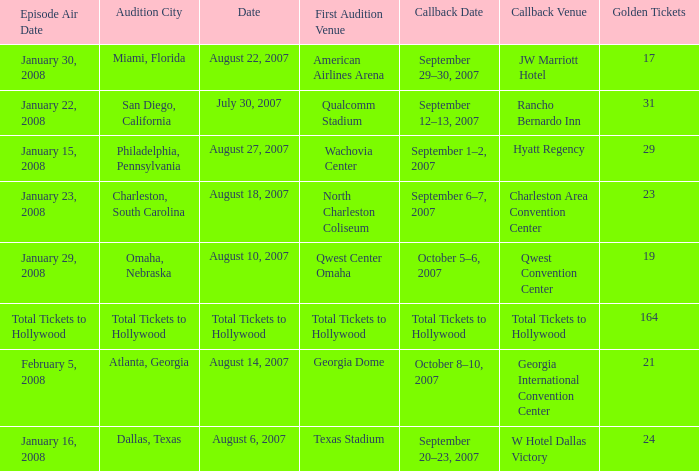How many golden tickets for the georgia international convention center? 21.0. I'm looking to parse the entire table for insights. Could you assist me with that? {'header': ['Episode Air Date', 'Audition City', 'Date', 'First Audition Venue', 'Callback Date', 'Callback Venue', 'Golden Tickets'], 'rows': [['January 30, 2008', 'Miami, Florida', 'August 22, 2007', 'American Airlines Arena', 'September 29–30, 2007', 'JW Marriott Hotel', '17'], ['January 22, 2008', 'San Diego, California', 'July 30, 2007', 'Qualcomm Stadium', 'September 12–13, 2007', 'Rancho Bernardo Inn', '31'], ['January 15, 2008', 'Philadelphia, Pennsylvania', 'August 27, 2007', 'Wachovia Center', 'September 1–2, 2007', 'Hyatt Regency', '29'], ['January 23, 2008', 'Charleston, South Carolina', 'August 18, 2007', 'North Charleston Coliseum', 'September 6–7, 2007', 'Charleston Area Convention Center', '23'], ['January 29, 2008', 'Omaha, Nebraska', 'August 10, 2007', 'Qwest Center Omaha', 'October 5–6, 2007', 'Qwest Convention Center', '19'], ['Total Tickets to Hollywood', 'Total Tickets to Hollywood', 'Total Tickets to Hollywood', 'Total Tickets to Hollywood', 'Total Tickets to Hollywood', 'Total Tickets to Hollywood', '164'], ['February 5, 2008', 'Atlanta, Georgia', 'August 14, 2007', 'Georgia Dome', 'October 8–10, 2007', 'Georgia International Convention Center', '21'], ['January 16, 2008', 'Dallas, Texas', 'August 6, 2007', 'Texas Stadium', 'September 20–23, 2007', 'W Hotel Dallas Victory', '24']]} 